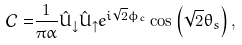Convert formula to latex. <formula><loc_0><loc_0><loc_500><loc_500>\mathcal { C } = & \frac { 1 } { \pi \alpha } \hat { U } _ { \downarrow } \hat { U } _ { \uparrow } e ^ { i \sqrt { 2 } \phi _ { c } } \cos \left ( \sqrt { 2 } \theta _ { s } \right ) ,</formula> 